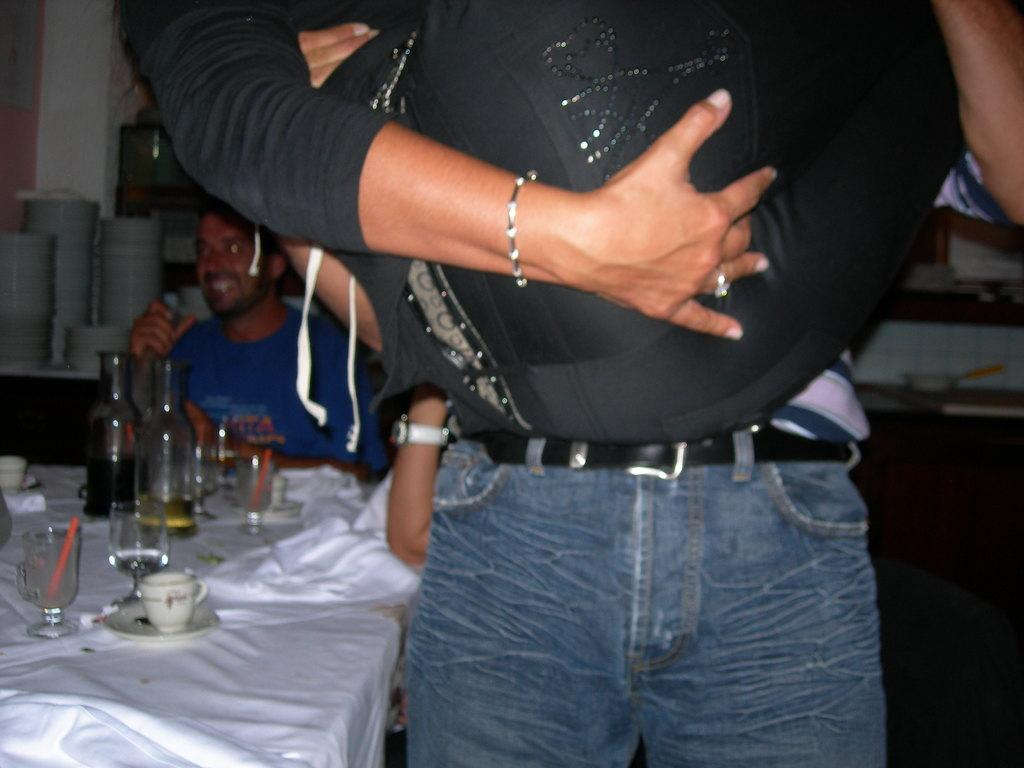What is the main subject of the image? There is a person standing in the image. What object can be seen near the person? There is a table in the image. What items are on the table? There are wine glasses and a wine bottle on the table. What type of brick is being used as a reward in the image? There is no brick or reward present in the image. Can you hear a whistle in the image? There is no whistle present in the image. 